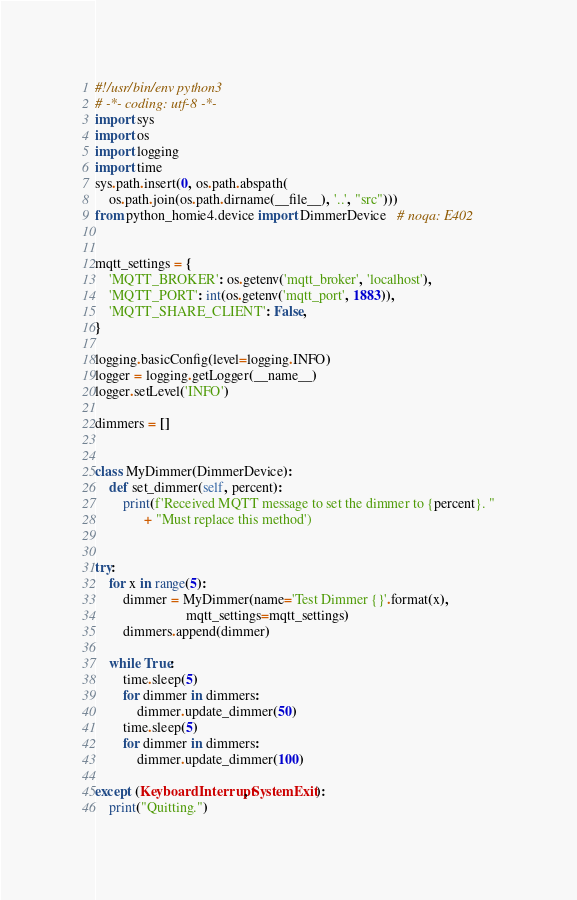Convert code to text. <code><loc_0><loc_0><loc_500><loc_500><_Python_>#!/usr/bin/env python3
# -*- coding: utf-8 -*-
import sys
import os
import logging
import time
sys.path.insert(0, os.path.abspath(
    os.path.join(os.path.dirname(__file__), '..', "src")))
from python_homie4.device import DimmerDevice   # noqa: E402


mqtt_settings = {
    'MQTT_BROKER': os.getenv('mqtt_broker', 'localhost'),
    'MQTT_PORT': int(os.getenv('mqtt_port', 1883)),
    'MQTT_SHARE_CLIENT': False,
}

logging.basicConfig(level=logging.INFO)
logger = logging.getLogger(__name__)
logger.setLevel('INFO')

dimmers = []


class MyDimmer(DimmerDevice):
    def set_dimmer(self, percent):
        print(f'Received MQTT message to set the dimmer to {percent}. "
              + "Must replace this method')


try:
    for x in range(5):
        dimmer = MyDimmer(name='Test Dimmer {}'.format(x),
                          mqtt_settings=mqtt_settings)
        dimmers.append(dimmer)

    while True:
        time.sleep(5)
        for dimmer in dimmers:
            dimmer.update_dimmer(50)
        time.sleep(5)
        for dimmer in dimmers:
            dimmer.update_dimmer(100)

except (KeyboardInterrupt, SystemExit):
    print("Quitting.")
</code> 